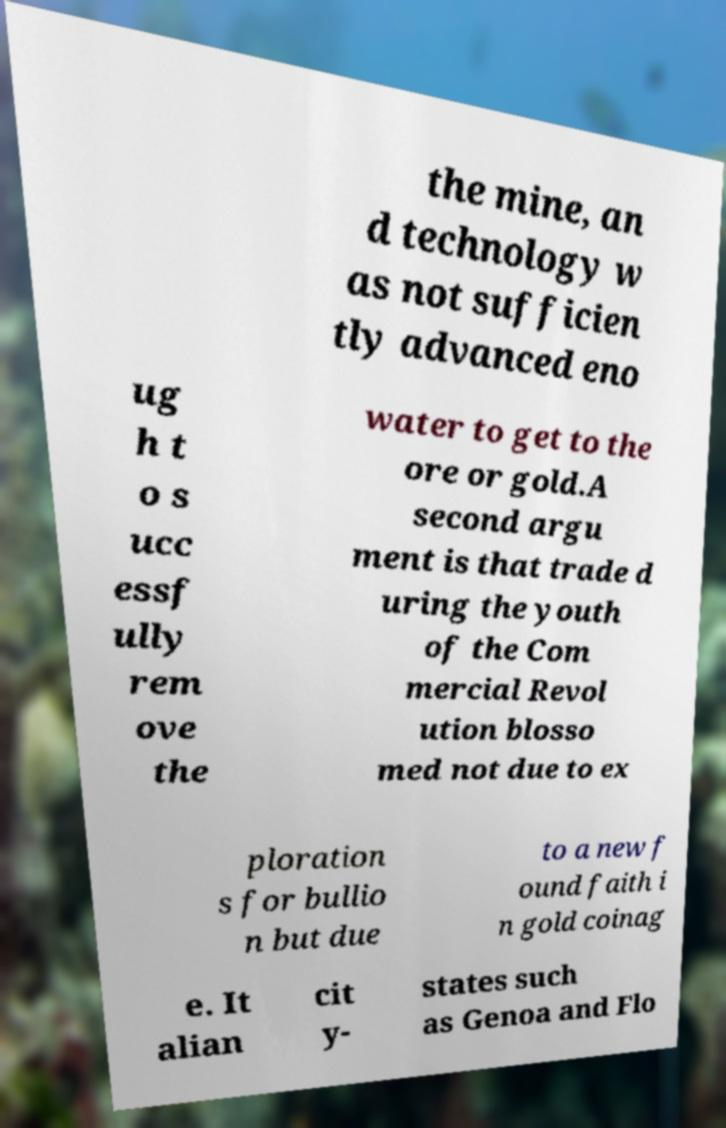What messages or text are displayed in this image? I need them in a readable, typed format. the mine, an d technology w as not sufficien tly advanced eno ug h t o s ucc essf ully rem ove the water to get to the ore or gold.A second argu ment is that trade d uring the youth of the Com mercial Revol ution blosso med not due to ex ploration s for bullio n but due to a new f ound faith i n gold coinag e. It alian cit y- states such as Genoa and Flo 